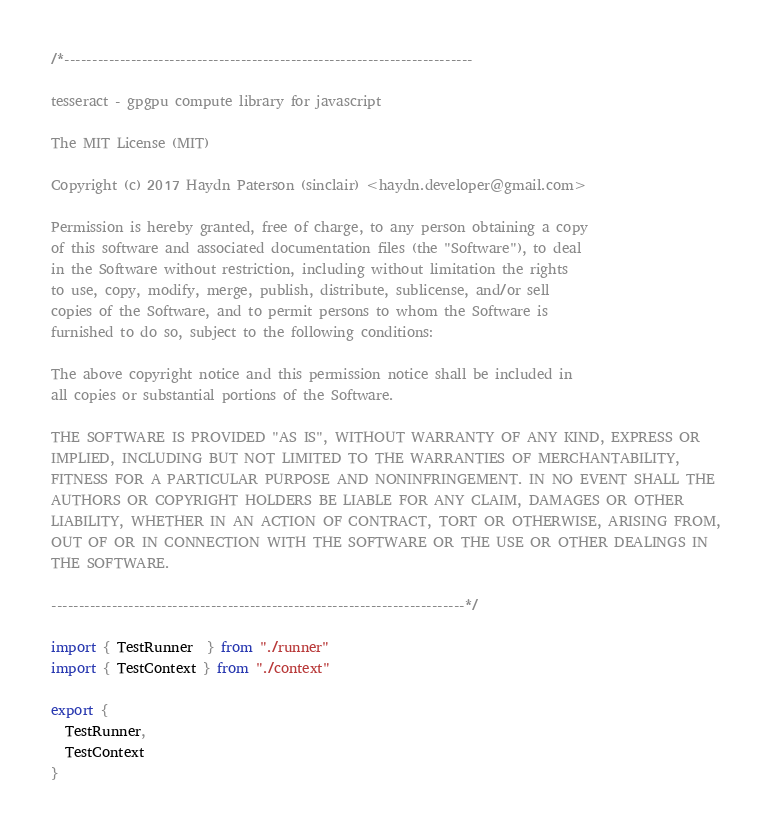Convert code to text. <code><loc_0><loc_0><loc_500><loc_500><_TypeScript_>/*--------------------------------------------------------------------------

tesseract - gpgpu compute library for javascript

The MIT License (MIT)

Copyright (c) 2017 Haydn Paterson (sinclair) <haydn.developer@gmail.com>

Permission is hereby granted, free of charge, to any person obtaining a copy
of this software and associated documentation files (the "Software"), to deal
in the Software without restriction, including without limitation the rights
to use, copy, modify, merge, publish, distribute, sublicense, and/or sell
copies of the Software, and to permit persons to whom the Software is
furnished to do so, subject to the following conditions:

The above copyright notice and this permission notice shall be included in
all copies or substantial portions of the Software.

THE SOFTWARE IS PROVIDED "AS IS", WITHOUT WARRANTY OF ANY KIND, EXPRESS OR
IMPLIED, INCLUDING BUT NOT LIMITED TO THE WARRANTIES OF MERCHANTABILITY,
FITNESS FOR A PARTICULAR PURPOSE AND NONINFRINGEMENT. IN NO EVENT SHALL THE
AUTHORS OR COPYRIGHT HOLDERS BE LIABLE FOR ANY CLAIM, DAMAGES OR OTHER
LIABILITY, WHETHER IN AN ACTION OF CONTRACT, TORT OR OTHERWISE, ARISING FROM,
OUT OF OR IN CONNECTION WITH THE SOFTWARE OR THE USE OR OTHER DEALINGS IN
THE SOFTWARE.

---------------------------------------------------------------------------*/

import { TestRunner  } from "./runner"
import { TestContext } from "./context"

export {
  TestRunner,
  TestContext
}</code> 